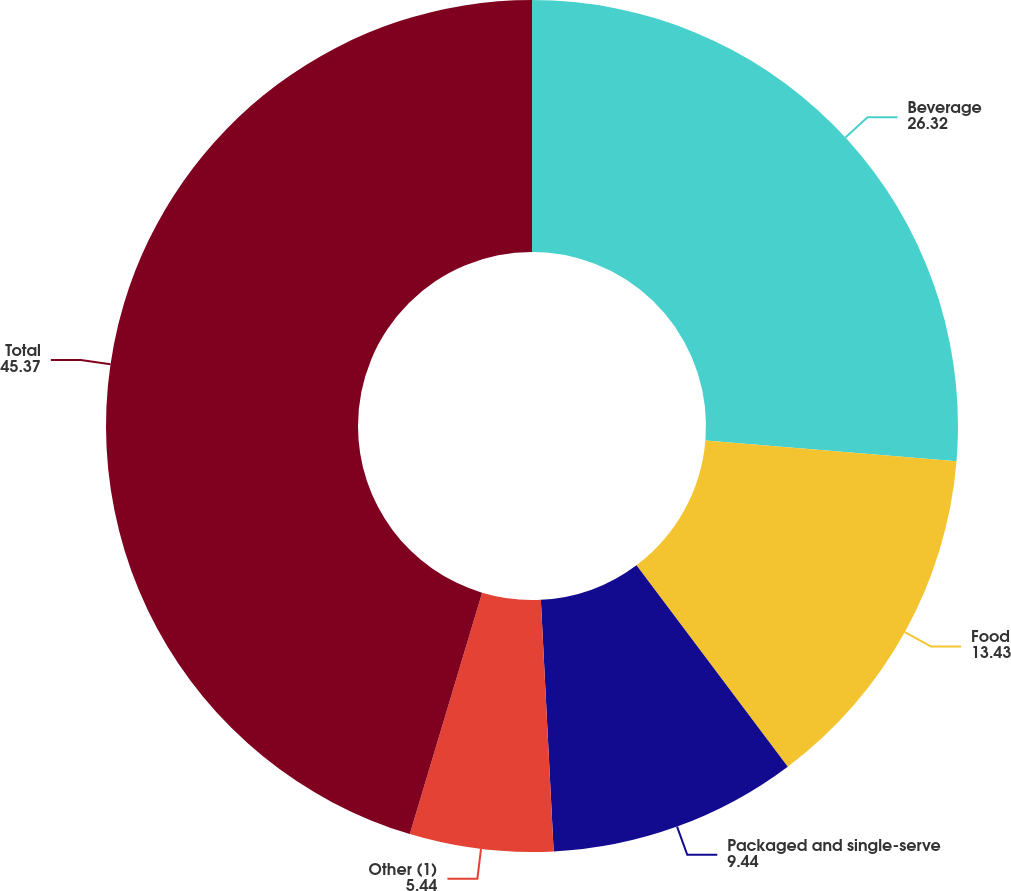Convert chart to OTSL. <chart><loc_0><loc_0><loc_500><loc_500><pie_chart><fcel>Beverage<fcel>Food<fcel>Packaged and single-serve<fcel>Other (1)<fcel>Total<nl><fcel>26.32%<fcel>13.43%<fcel>9.44%<fcel>5.44%<fcel>45.37%<nl></chart> 